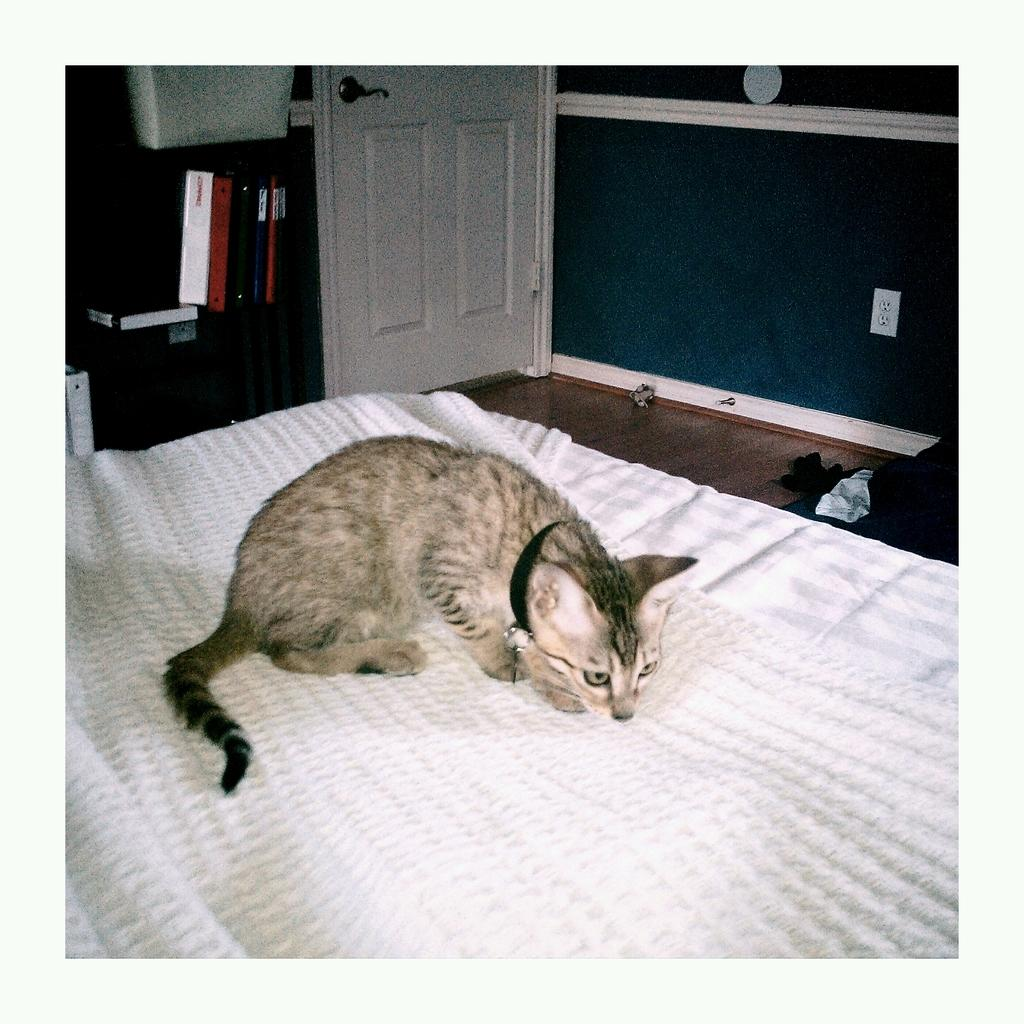What type of animal is on the bed in the image? There is a cat on a bed in the image. What can be seen in the background of the image? There are books and a door in the background of the image. What type of bottle is the laborer holding in the image? There is no laborer or bottle present in the image. 